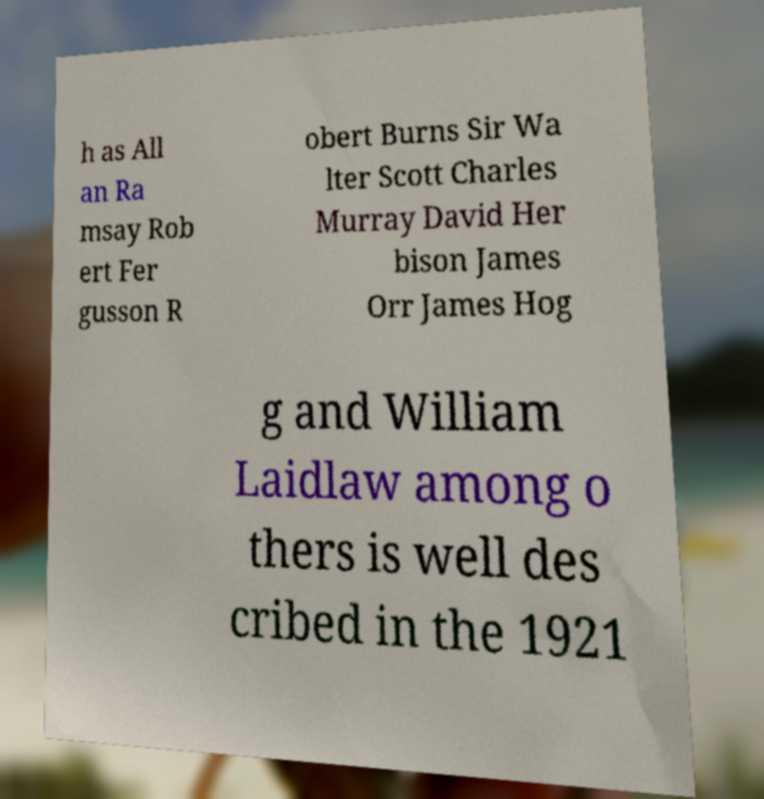There's text embedded in this image that I need extracted. Can you transcribe it verbatim? h as All an Ra msay Rob ert Fer gusson R obert Burns Sir Wa lter Scott Charles Murray David Her bison James Orr James Hog g and William Laidlaw among o thers is well des cribed in the 1921 